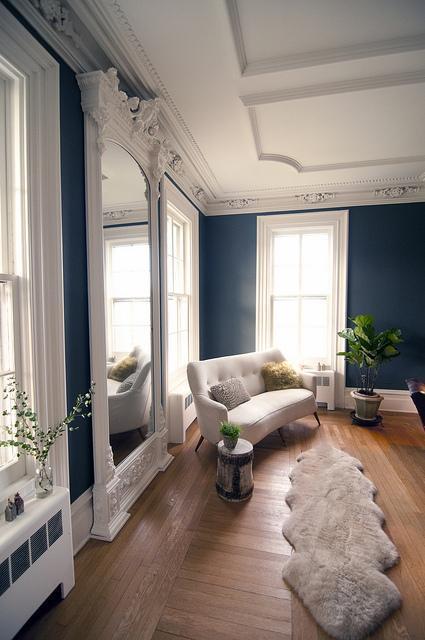How many plants are there?
Give a very brief answer. 3. 